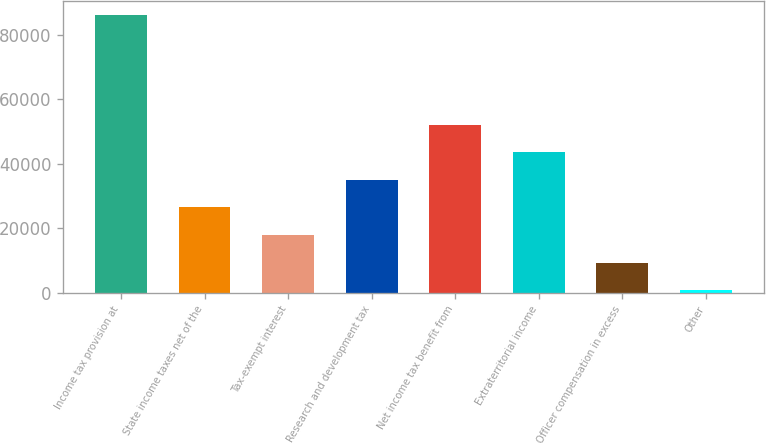Convert chart to OTSL. <chart><loc_0><loc_0><loc_500><loc_500><bar_chart><fcel>Income tax provision at<fcel>State income taxes net of the<fcel>Tax-exempt interest<fcel>Research and development tax<fcel>Net income tax benefit from<fcel>Extraterritorial income<fcel>Officer compensation in excess<fcel>Other<nl><fcel>86215<fcel>26460.2<fcel>17923.8<fcel>34996.6<fcel>52069.4<fcel>43533<fcel>9387.4<fcel>851<nl></chart> 